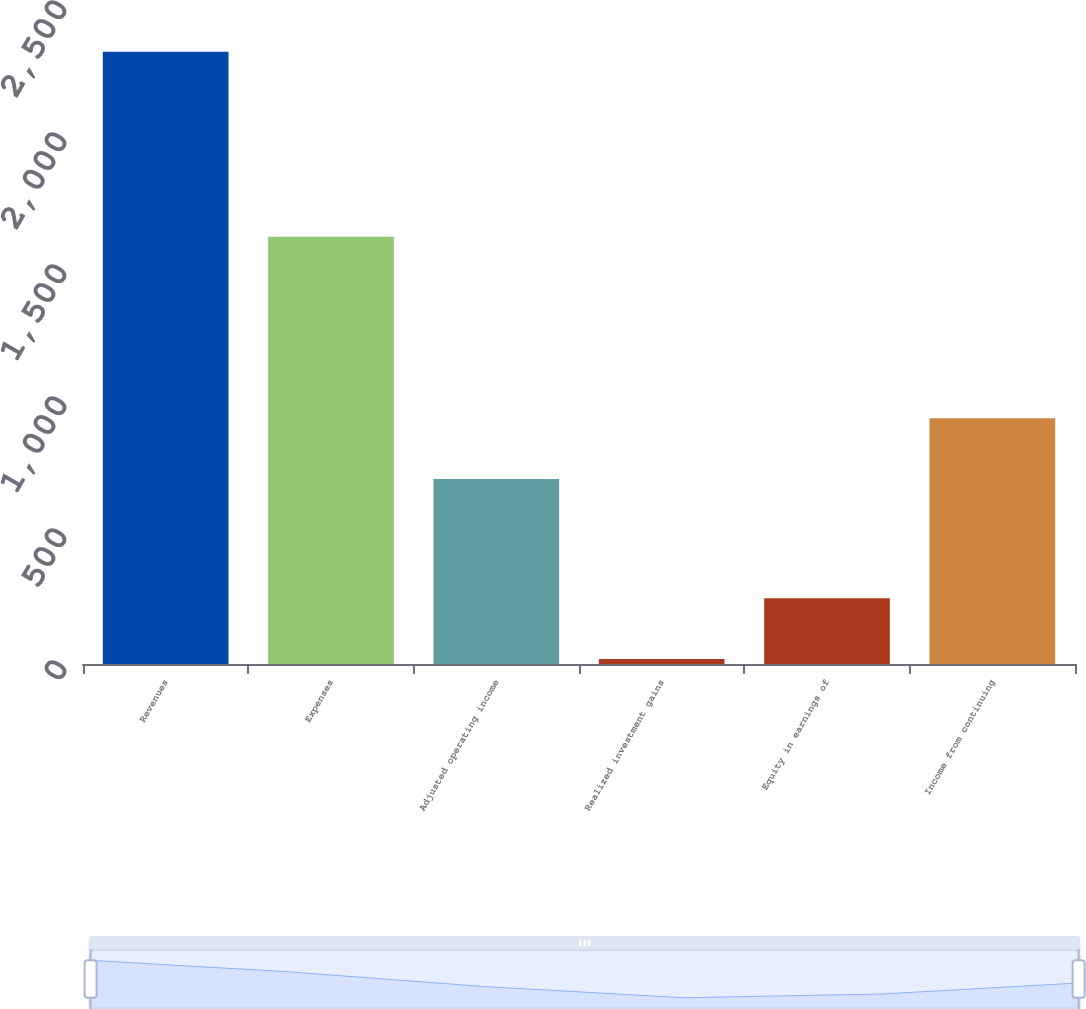<chart> <loc_0><loc_0><loc_500><loc_500><bar_chart><fcel>Revenues<fcel>Expenses<fcel>Adjusted operating income<fcel>Realized investment gains<fcel>Equity in earnings of<fcel>Income from continuing<nl><fcel>2319<fcel>1618<fcel>701<fcel>19<fcel>249<fcel>931<nl></chart> 